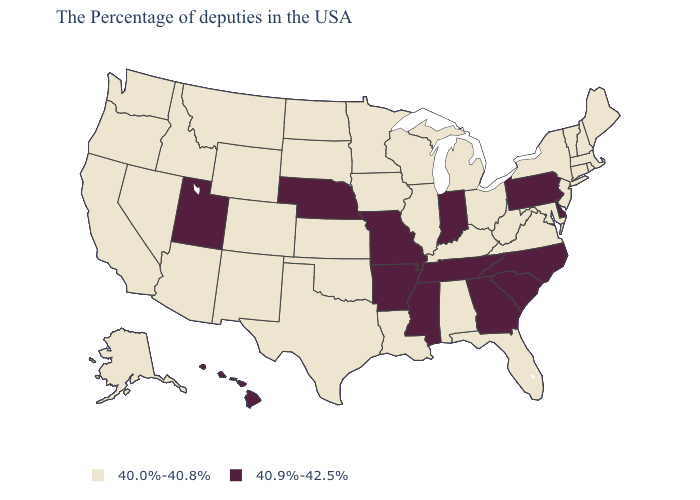What is the value of Oregon?
Give a very brief answer. 40.0%-40.8%. What is the value of Missouri?
Concise answer only. 40.9%-42.5%. What is the value of Florida?
Keep it brief. 40.0%-40.8%. What is the value of Iowa?
Answer briefly. 40.0%-40.8%. Which states have the lowest value in the USA?
Answer briefly. Maine, Massachusetts, Rhode Island, New Hampshire, Vermont, Connecticut, New York, New Jersey, Maryland, Virginia, West Virginia, Ohio, Florida, Michigan, Kentucky, Alabama, Wisconsin, Illinois, Louisiana, Minnesota, Iowa, Kansas, Oklahoma, Texas, South Dakota, North Dakota, Wyoming, Colorado, New Mexico, Montana, Arizona, Idaho, Nevada, California, Washington, Oregon, Alaska. What is the lowest value in the Northeast?
Concise answer only. 40.0%-40.8%. Does the first symbol in the legend represent the smallest category?
Be succinct. Yes. What is the value of Minnesota?
Concise answer only. 40.0%-40.8%. Does the map have missing data?
Write a very short answer. No. Which states hav the highest value in the West?
Write a very short answer. Utah, Hawaii. What is the value of Iowa?
Concise answer only. 40.0%-40.8%. Does Indiana have the highest value in the MidWest?
Short answer required. Yes. What is the value of Virginia?
Write a very short answer. 40.0%-40.8%. Among the states that border Indiana , which have the highest value?
Concise answer only. Ohio, Michigan, Kentucky, Illinois. 